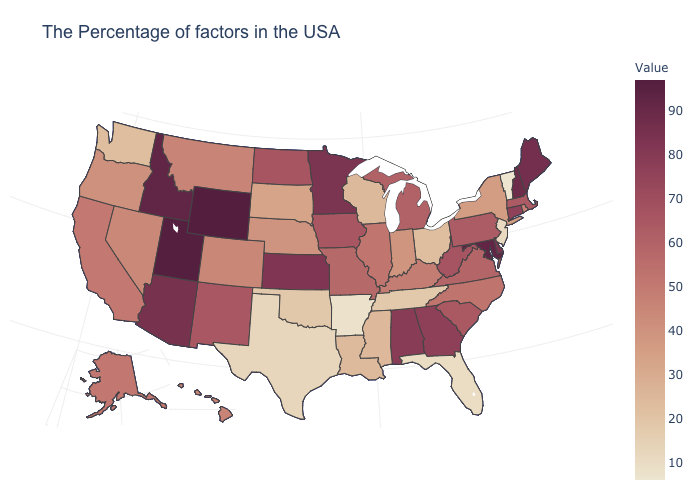Does New York have the lowest value in the Northeast?
Be succinct. No. Does Michigan have the lowest value in the MidWest?
Short answer required. No. Does Colorado have the highest value in the USA?
Keep it brief. No. Does Pennsylvania have the lowest value in the USA?
Concise answer only. No. 